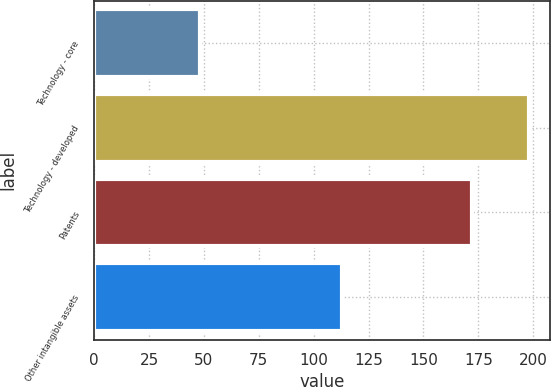Convert chart to OTSL. <chart><loc_0><loc_0><loc_500><loc_500><bar_chart><fcel>Technology - core<fcel>Technology - developed<fcel>Patents<fcel>Other intangible assets<nl><fcel>48<fcel>198<fcel>172<fcel>113<nl></chart> 